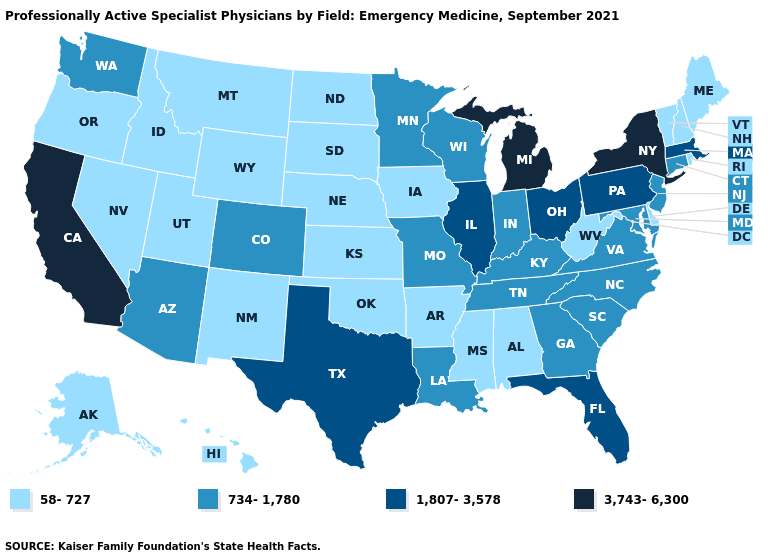Does North Dakota have the highest value in the MidWest?
Quick response, please. No. Does California have the highest value in the West?
Be succinct. Yes. What is the highest value in the West ?
Concise answer only. 3,743-6,300. Which states have the highest value in the USA?
Answer briefly. California, Michigan, New York. Among the states that border Michigan , which have the highest value?
Quick response, please. Ohio. What is the value of Wisconsin?
Concise answer only. 734-1,780. What is the highest value in the USA?
Keep it brief. 3,743-6,300. Does New York have the highest value in the Northeast?
Concise answer only. Yes. What is the highest value in the USA?
Be succinct. 3,743-6,300. Name the states that have a value in the range 1,807-3,578?
Give a very brief answer. Florida, Illinois, Massachusetts, Ohio, Pennsylvania, Texas. Name the states that have a value in the range 734-1,780?
Be succinct. Arizona, Colorado, Connecticut, Georgia, Indiana, Kentucky, Louisiana, Maryland, Minnesota, Missouri, New Jersey, North Carolina, South Carolina, Tennessee, Virginia, Washington, Wisconsin. Among the states that border Arizona , does Utah have the highest value?
Quick response, please. No. Does the first symbol in the legend represent the smallest category?
Be succinct. Yes. Name the states that have a value in the range 734-1,780?
Short answer required. Arizona, Colorado, Connecticut, Georgia, Indiana, Kentucky, Louisiana, Maryland, Minnesota, Missouri, New Jersey, North Carolina, South Carolina, Tennessee, Virginia, Washington, Wisconsin. 